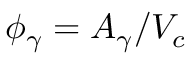<formula> <loc_0><loc_0><loc_500><loc_500>\phi _ { \gamma } = A _ { \gamma } / V _ { c }</formula> 